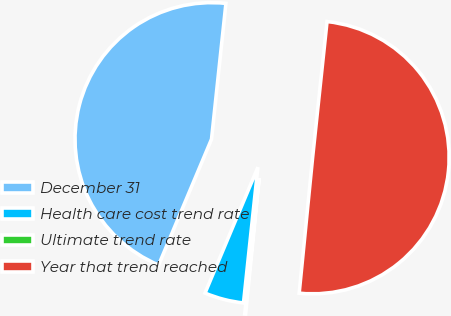Convert chart. <chart><loc_0><loc_0><loc_500><loc_500><pie_chart><fcel>December 31<fcel>Health care cost trend rate<fcel>Ultimate trend rate<fcel>Year that trend reached<nl><fcel>45.35%<fcel>4.65%<fcel>0.11%<fcel>49.89%<nl></chart> 